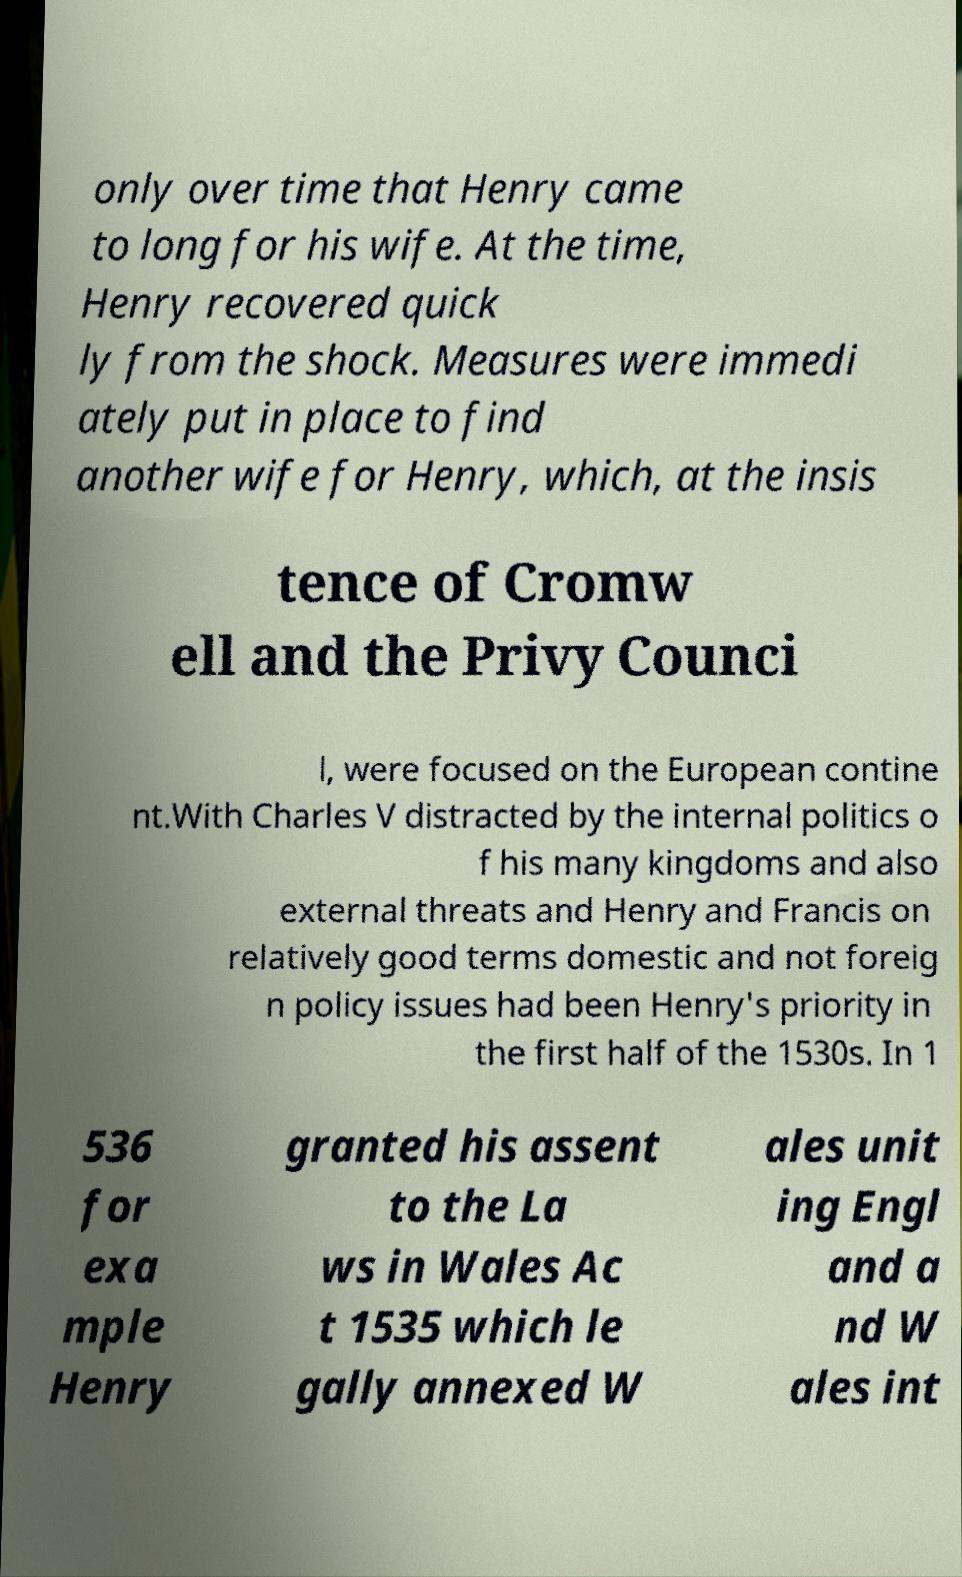There's text embedded in this image that I need extracted. Can you transcribe it verbatim? only over time that Henry came to long for his wife. At the time, Henry recovered quick ly from the shock. Measures were immedi ately put in place to find another wife for Henry, which, at the insis tence of Cromw ell and the Privy Counci l, were focused on the European contine nt.With Charles V distracted by the internal politics o f his many kingdoms and also external threats and Henry and Francis on relatively good terms domestic and not foreig n policy issues had been Henry's priority in the first half of the 1530s. In 1 536 for exa mple Henry granted his assent to the La ws in Wales Ac t 1535 which le gally annexed W ales unit ing Engl and a nd W ales int 